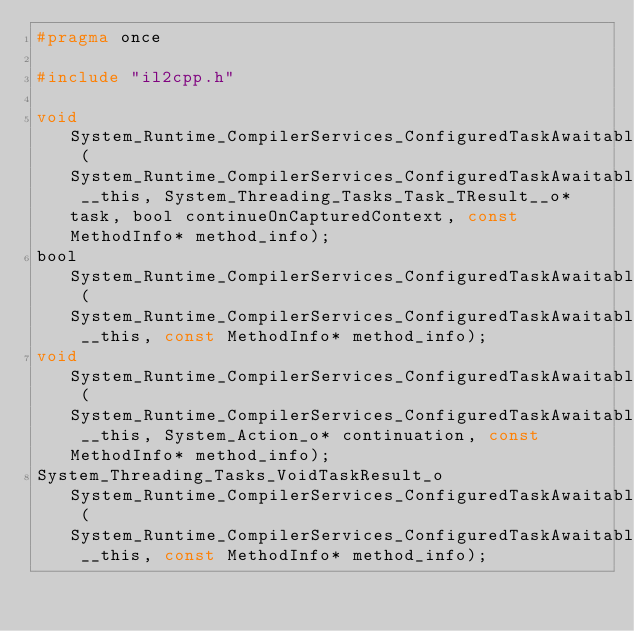Convert code to text. <code><loc_0><loc_0><loc_500><loc_500><_C_>#pragma once

#include "il2cpp.h"

void System_Runtime_CompilerServices_ConfiguredTaskAwaitable_ConfiguredTaskAwaiter_VoidTaskResult____ctor (System_Runtime_CompilerServices_ConfiguredTaskAwaitable_ConfiguredTaskAwaiter_VoidTaskResult__o __this, System_Threading_Tasks_Task_TResult__o* task, bool continueOnCapturedContext, const MethodInfo* method_info);
bool System_Runtime_CompilerServices_ConfiguredTaskAwaitable_ConfiguredTaskAwaiter_VoidTaskResult___get_IsCompleted (System_Runtime_CompilerServices_ConfiguredTaskAwaitable_ConfiguredTaskAwaiter_VoidTaskResult__o __this, const MethodInfo* method_info);
void System_Runtime_CompilerServices_ConfiguredTaskAwaitable_ConfiguredTaskAwaiter_VoidTaskResult___UnsafeOnCompleted (System_Runtime_CompilerServices_ConfiguredTaskAwaitable_ConfiguredTaskAwaiter_VoidTaskResult__o __this, System_Action_o* continuation, const MethodInfo* method_info);
System_Threading_Tasks_VoidTaskResult_o System_Runtime_CompilerServices_ConfiguredTaskAwaitable_ConfiguredTaskAwaiter_VoidTaskResult___GetResult (System_Runtime_CompilerServices_ConfiguredTaskAwaitable_ConfiguredTaskAwaiter_VoidTaskResult__o __this, const MethodInfo* method_info);
</code> 